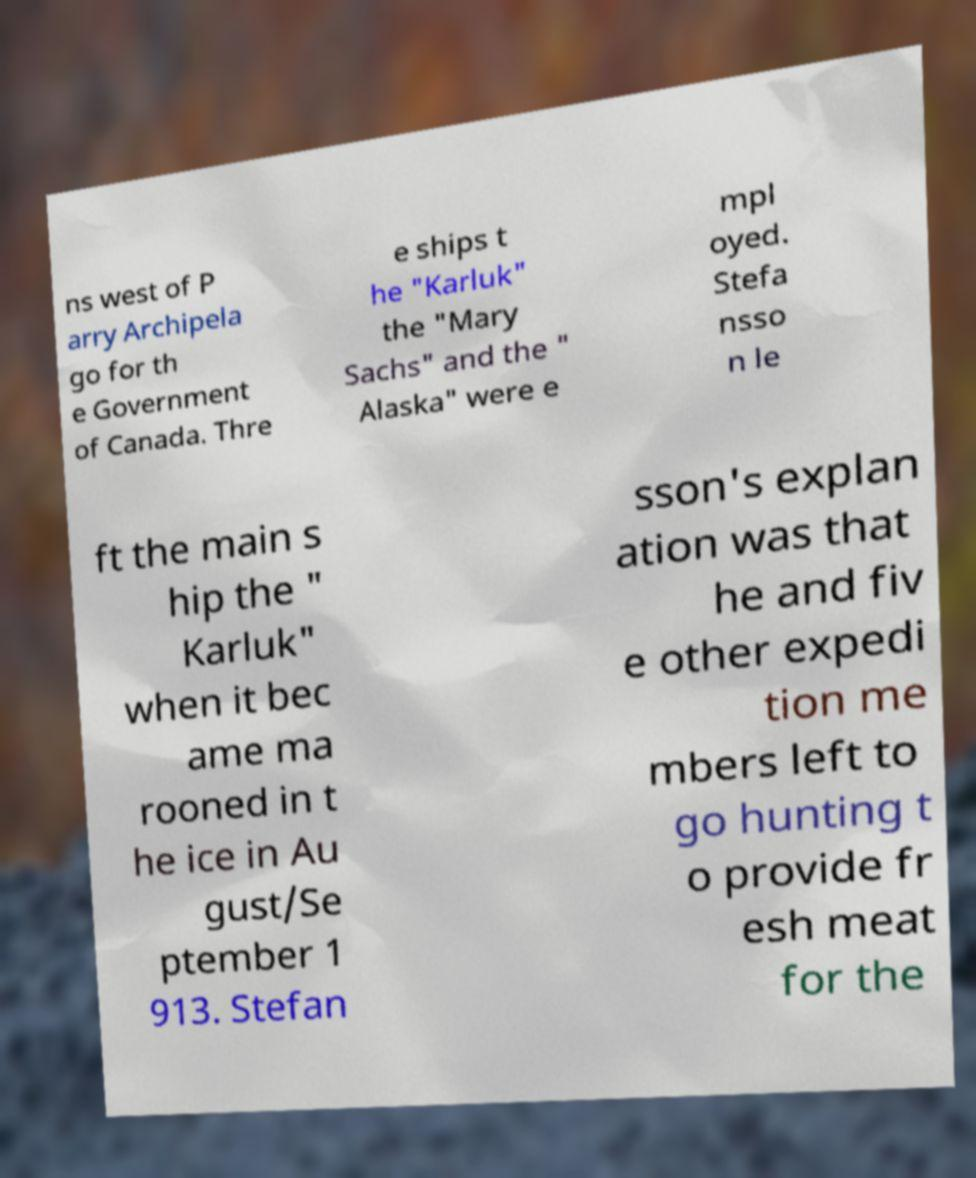Could you extract and type out the text from this image? ns west of P arry Archipela go for th e Government of Canada. Thre e ships t he "Karluk" the "Mary Sachs" and the " Alaska" were e mpl oyed. Stefa nsso n le ft the main s hip the " Karluk" when it bec ame ma rooned in t he ice in Au gust/Se ptember 1 913. Stefan sson's explan ation was that he and fiv e other expedi tion me mbers left to go hunting t o provide fr esh meat for the 